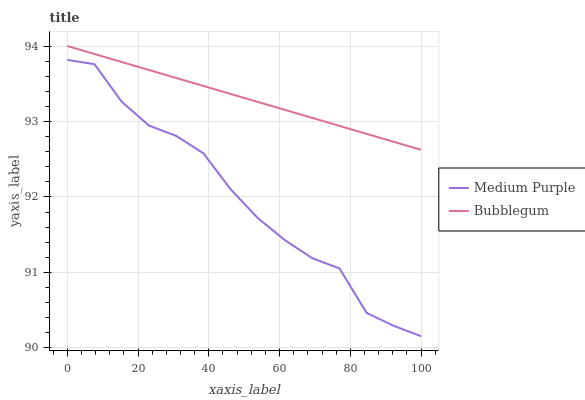Does Medium Purple have the minimum area under the curve?
Answer yes or no. Yes. Does Bubblegum have the maximum area under the curve?
Answer yes or no. Yes. Does Bubblegum have the minimum area under the curve?
Answer yes or no. No. Is Bubblegum the smoothest?
Answer yes or no. Yes. Is Medium Purple the roughest?
Answer yes or no. Yes. Is Bubblegum the roughest?
Answer yes or no. No. Does Medium Purple have the lowest value?
Answer yes or no. Yes. Does Bubblegum have the lowest value?
Answer yes or no. No. Does Bubblegum have the highest value?
Answer yes or no. Yes. Is Medium Purple less than Bubblegum?
Answer yes or no. Yes. Is Bubblegum greater than Medium Purple?
Answer yes or no. Yes. Does Medium Purple intersect Bubblegum?
Answer yes or no. No. 